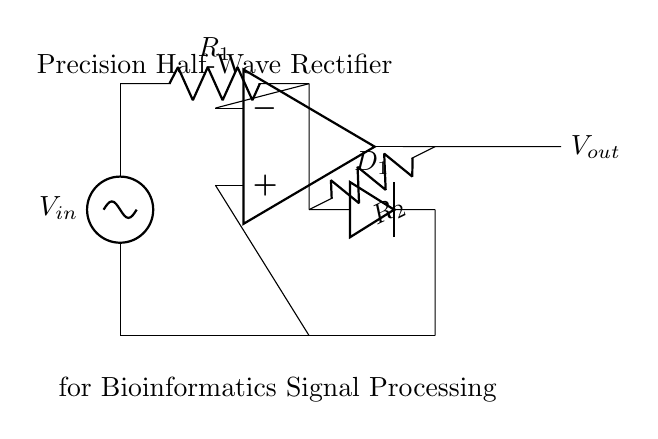What type of rectifier is represented in the circuit? The circuit depicts a precision half-wave rectifier, characterized by its use of an operational amplifier and a diode for rectifying the input signal.
Answer: precision half-wave rectifier What component implements the rectification in this circuit? The diode labeled D1 is the component that allows current to flow only in one direction, effectively rectifying the input voltage.
Answer: D1 What is the role of the operational amplifier in this circuit? The operational amplifier amplifies the input signal and controls the output to ensure precision during rectification, maintaining a low output impedance.
Answer: amplification What is the value of R1 in the circuit based on its labeling? R1 is labeled at the position where the input signal passes through, playing a role in determining the gain and bandwidth of the circuit.
Answer: R1 How does the feedback loop affect the operation of the precision rectifier? The feedback loop, formed by the resistor R2, ensures that the output follows the input closely, enabling precise control of the output voltage and decreasing distortion.
Answer: controls output What is the expected behavior of the output voltage when the input voltage is negative? When the input voltage is negative, the diode D1 blocks the current flow, leading to an output voltage of zero volts during that phase.
Answer: zero volts What is the significance of the label indicating 'for Bioinformatics Signal Processing'? This labeling signifies that the rectifier is specifically designed for applications in bioinformatics, where accurate signal rectification of biological data is crucial.
Answer: bioinformatics application 